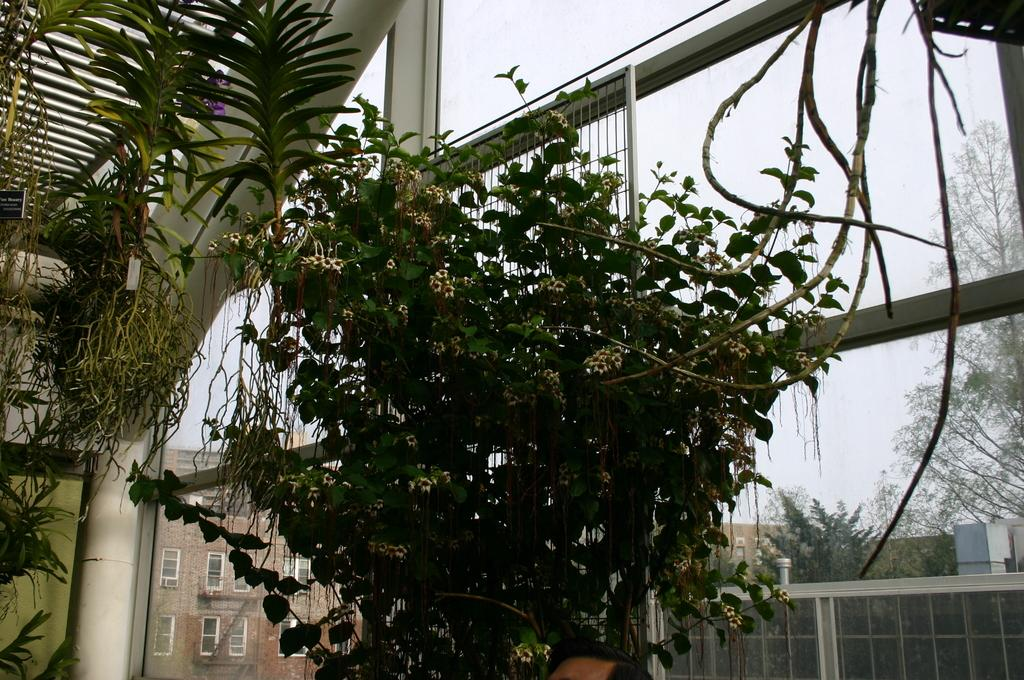What type of natural elements can be seen in the image? There are plants and trees in the image. What type of man-made structures can be seen in the image? There are buildings in the image. What is visible in the sky in the image? The sky is visible in the image. What architectural feature can be seen in the image? There is a glass wall in the image. What part of a building can be seen in the image? The roof is visible in the image. Can you see a horse using a toothbrush during a rainstorm in the image? No, there is no horse, toothbrush, or rainstorm present in the image. 